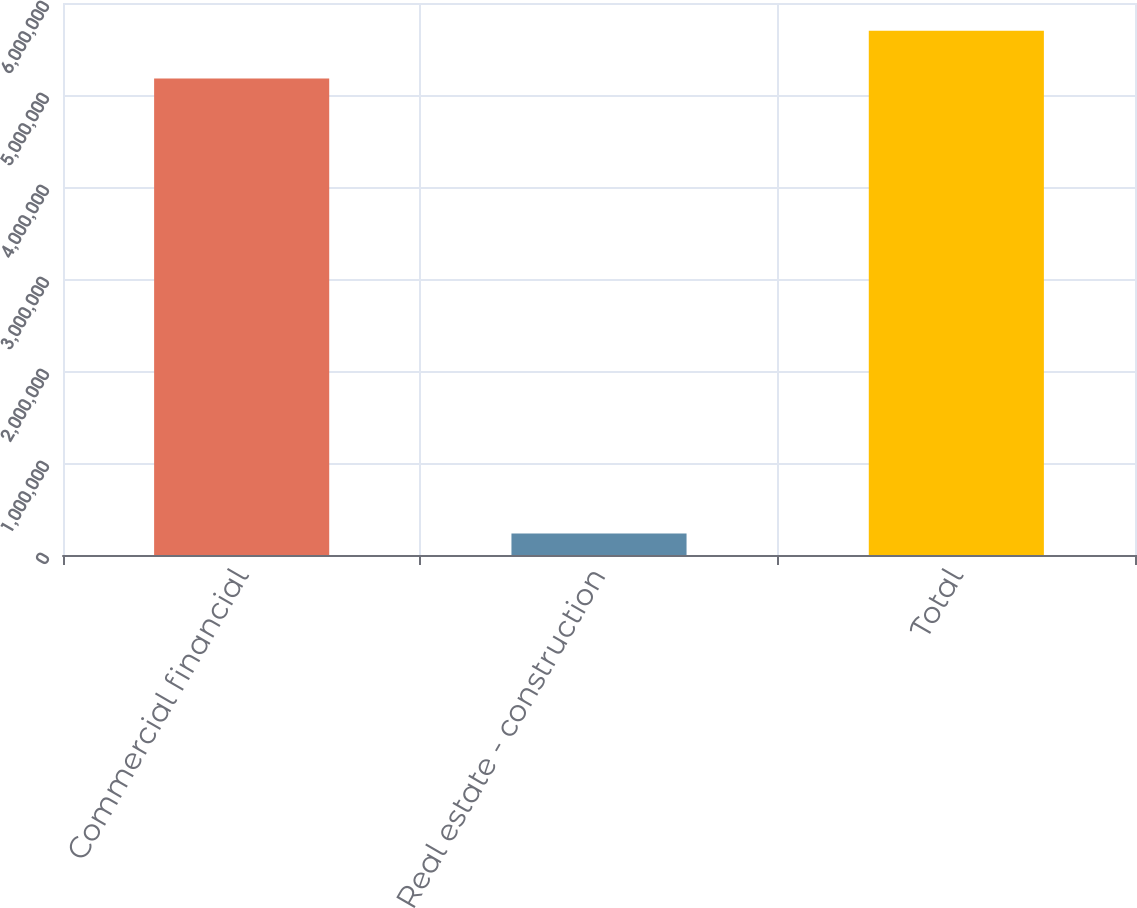<chart> <loc_0><loc_0><loc_500><loc_500><bar_chart><fcel>Commercial financial<fcel>Real estate - construction<fcel>Total<nl><fcel>5.18033e+06<fcel>232509<fcel>5.69836e+06<nl></chart> 